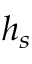<formula> <loc_0><loc_0><loc_500><loc_500>h _ { s }</formula> 